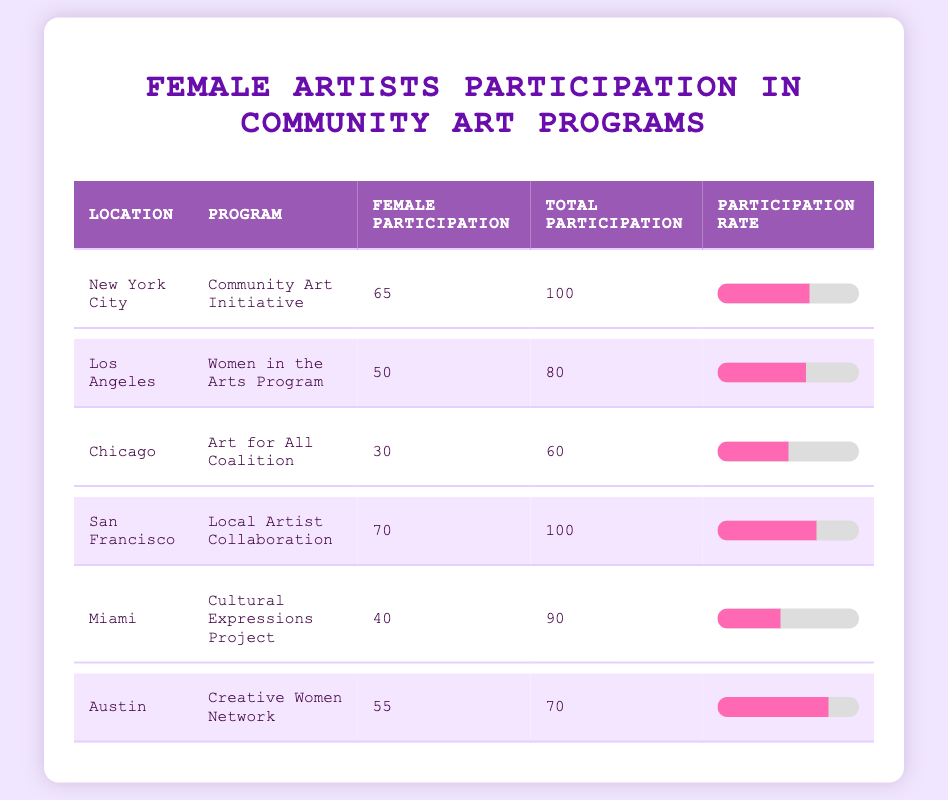What is the female artists' participation in the Community Art Initiative in New York City? The table shows that the female artists' participation in the Community Art Initiative in New York City is listed as 65.
Answer: 65 Which program in Los Angeles has a participation rate of 62.5%? The table indicates the Women in the Arts Program in Los Angeles has a female artists' participation of 50 out of 80 total artists, resulting in a participation rate of 62.5%.
Answer: Women in the Arts Program What is the total number of artists participating in the Art for All Coalition in Chicago? According to the data, the total number of artists participating in the Art for All Coalition in Chicago is 60.
Answer: 60 Is the female artists' participation in Miami higher than that in Chicago? In Miami, female artists' participation is 40 out of 90 total artists (44.4%), while in Chicago it is 30 out of 60 total artists (50%). Therefore, the participation is higher in Chicago.
Answer: No What is the average female artists' participation across all locations listed in the table? To find the average, we sum the female artists' participation values: 65 + 50 + 30 + 70 + 40 + 55 = 310. Then, divide by the number of locations, which is 6. So, the average is 310/6 = approximately 51.67.
Answer: 51.67 Which location has the highest female participation rate, and what is the rate? San Francisco has the highest female participation at 70 out of 100 total artists, yielding a participation rate of 70%. Comparing the rates, San Francisco's rate is the highest among the listed locations.
Answer: San Francisco, 70% How does the female artists' participation in Austin compare to that in New York City? In Austin, female artists' participation is 55 out of 70 total artists, resulting in a participation rate of approximately 78.6%, while in New York City, it is 65 out of 100 total artists (65%). Thus, Austin has a higher participation rate compared to New York City.
Answer: Higher in Austin What are the total female artists' participations combined for the programs in New York City and San Francisco? The female artists' participation for New York City is 65 and for San Francisco is 70. To find the combined total, we add these two values: 65 + 70 = 135.
Answer: 135 Is the female artists' participation in the Creative Women Network in Austin greater than 50%? In Austin, the participation is 55 out of 70 total artists, which gives a rate of approximately 78.6%. Since 78.6% is greater than 50%, the statement is true.
Answer: Yes 